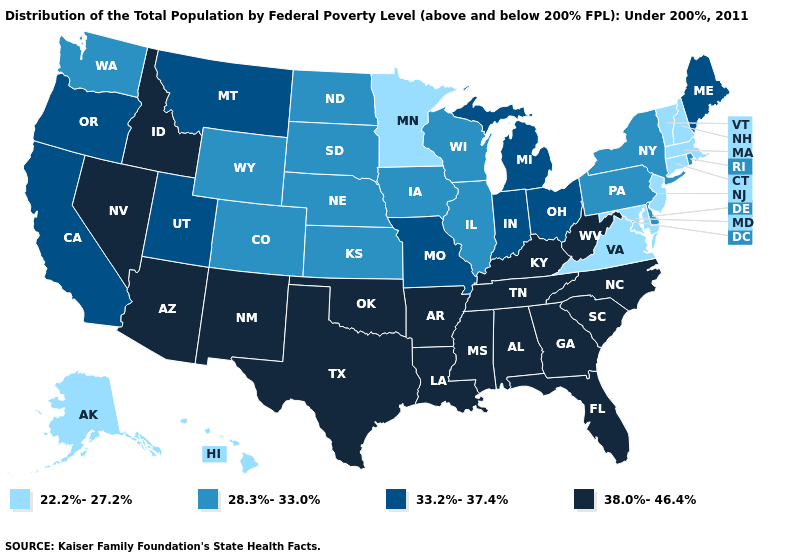What is the value of Vermont?
Short answer required. 22.2%-27.2%. Does the first symbol in the legend represent the smallest category?
Concise answer only. Yes. Name the states that have a value in the range 22.2%-27.2%?
Give a very brief answer. Alaska, Connecticut, Hawaii, Maryland, Massachusetts, Minnesota, New Hampshire, New Jersey, Vermont, Virginia. What is the highest value in states that border New Jersey?
Write a very short answer. 28.3%-33.0%. Name the states that have a value in the range 33.2%-37.4%?
Concise answer only. California, Indiana, Maine, Michigan, Missouri, Montana, Ohio, Oregon, Utah. Does Massachusetts have the lowest value in the Northeast?
Answer briefly. Yes. How many symbols are there in the legend?
Answer briefly. 4. Does California have the lowest value in the USA?
Short answer required. No. Which states have the highest value in the USA?
Keep it brief. Alabama, Arizona, Arkansas, Florida, Georgia, Idaho, Kentucky, Louisiana, Mississippi, Nevada, New Mexico, North Carolina, Oklahoma, South Carolina, Tennessee, Texas, West Virginia. Which states have the lowest value in the USA?
Write a very short answer. Alaska, Connecticut, Hawaii, Maryland, Massachusetts, Minnesota, New Hampshire, New Jersey, Vermont, Virginia. Name the states that have a value in the range 22.2%-27.2%?
Be succinct. Alaska, Connecticut, Hawaii, Maryland, Massachusetts, Minnesota, New Hampshire, New Jersey, Vermont, Virginia. Among the states that border Wyoming , does Nebraska have the highest value?
Quick response, please. No. Name the states that have a value in the range 33.2%-37.4%?
Short answer required. California, Indiana, Maine, Michigan, Missouri, Montana, Ohio, Oregon, Utah. What is the lowest value in states that border Delaware?
Answer briefly. 22.2%-27.2%. Name the states that have a value in the range 33.2%-37.4%?
Short answer required. California, Indiana, Maine, Michigan, Missouri, Montana, Ohio, Oregon, Utah. 